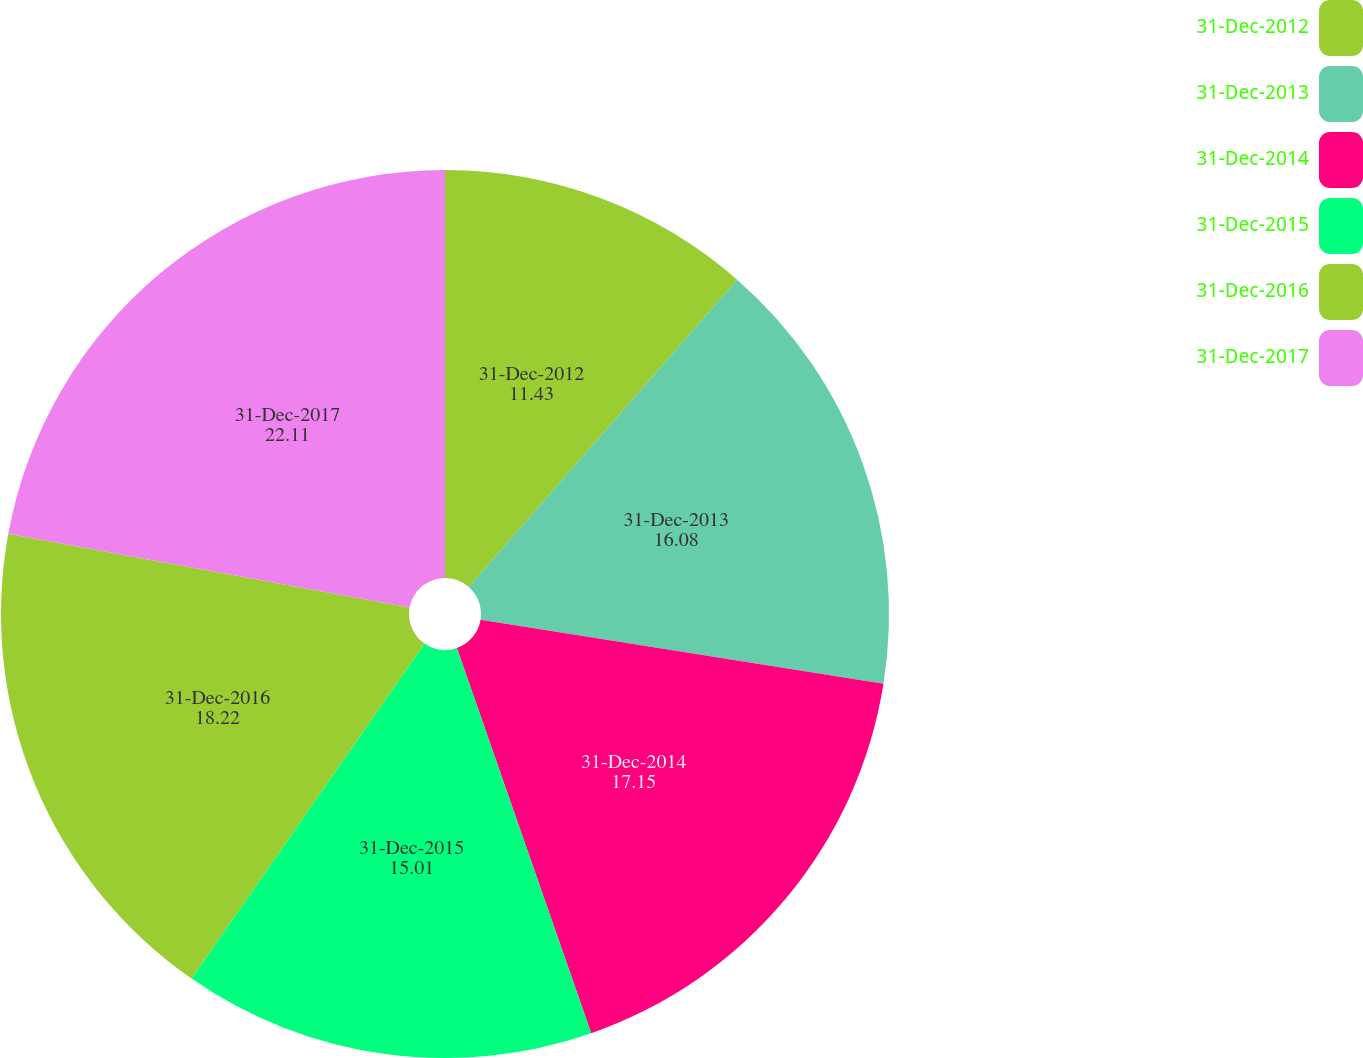Convert chart. <chart><loc_0><loc_0><loc_500><loc_500><pie_chart><fcel>31-Dec-2012<fcel>31-Dec-2013<fcel>31-Dec-2014<fcel>31-Dec-2015<fcel>31-Dec-2016<fcel>31-Dec-2017<nl><fcel>11.43%<fcel>16.08%<fcel>17.15%<fcel>15.01%<fcel>18.22%<fcel>22.11%<nl></chart> 